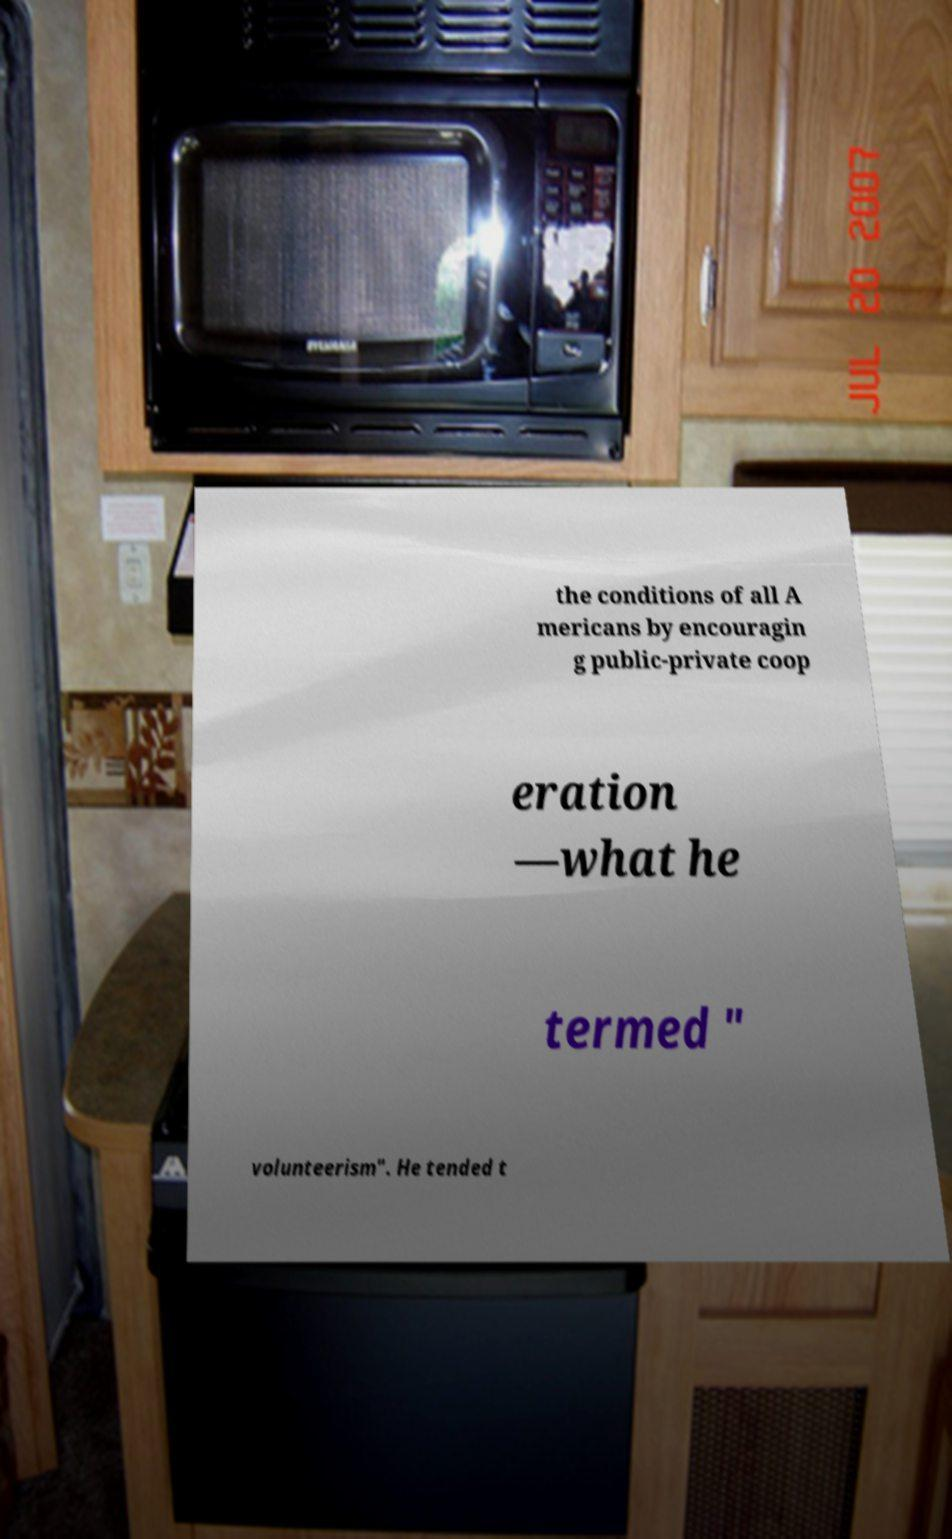For documentation purposes, I need the text within this image transcribed. Could you provide that? the conditions of all A mericans by encouragin g public-private coop eration —what he termed " volunteerism". He tended t 